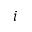<formula> <loc_0><loc_0><loc_500><loc_500>i</formula> 